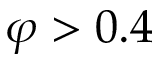Convert formula to latex. <formula><loc_0><loc_0><loc_500><loc_500>\varphi > 0 . 4</formula> 